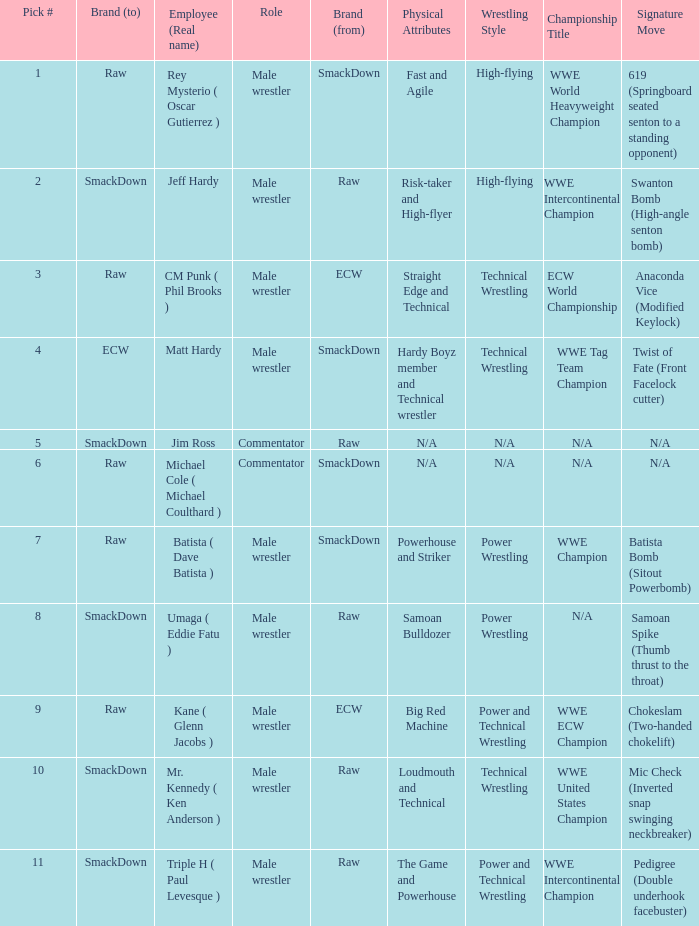What is the real name of the Pick # that is greater than 9? Mr. Kennedy ( Ken Anderson ), Triple H ( Paul Levesque ). Could you help me parse every detail presented in this table? {'header': ['Pick #', 'Brand (to)', 'Employee (Real name)', 'Role', 'Brand (from)', 'Physical Attributes', 'Wrestling Style', 'Championship Title', 'Signature Move'], 'rows': [['1', 'Raw', 'Rey Mysterio ( Oscar Gutierrez )', 'Male wrestler', 'SmackDown', 'Fast and Agile ', 'High-flying', 'WWE World Heavyweight Champion', '619 (Springboard seated senton to a standing opponent)'], ['2', 'SmackDown', 'Jeff Hardy', 'Male wrestler', 'Raw', 'Risk-taker and High-flyer', 'High-flying', 'WWE Intercontinental Champion', 'Swanton Bomb (High-angle senton bomb)'], ['3', 'Raw', 'CM Punk ( Phil Brooks )', 'Male wrestler', 'ECW', 'Straight Edge and Technical', 'Technical Wrestling', 'ECW World Championship', 'Anaconda Vice (Modified Keylock)'], ['4', 'ECW', 'Matt Hardy', 'Male wrestler', 'SmackDown', 'Hardy Boyz member and Technical wrestler', 'Technical Wrestling', 'WWE Tag Team Champion', 'Twist of Fate (Front Facelock cutter)'], ['5', 'SmackDown', 'Jim Ross', 'Commentator', 'Raw', 'N/A', 'N/A', 'N/A', 'N/A'], ['6', 'Raw', 'Michael Cole ( Michael Coulthard )', 'Commentator', 'SmackDown', 'N/A', 'N/A', 'N/A', 'N/A'], ['7', 'Raw', 'Batista ( Dave Batista )', 'Male wrestler', 'SmackDown', 'Powerhouse and Striker', 'Power Wrestling', 'WWE Champion', 'Batista Bomb (Sitout Powerbomb)'], ['8', 'SmackDown', 'Umaga ( Eddie Fatu )', 'Male wrestler', 'Raw', 'Samoan Bulldozer', 'Power Wrestling', 'N/A', 'Samoan Spike (Thumb thrust to the throat)'], ['9', 'Raw', 'Kane ( Glenn Jacobs )', 'Male wrestler', 'ECW', 'Big Red Machine', 'Power and Technical Wrestling', 'WWE ECW Champion', 'Chokeslam (Two-handed chokelift)'], ['10', 'SmackDown', 'Mr. Kennedy ( Ken Anderson )', 'Male wrestler', 'Raw', 'Loudmouth and Technical', 'Technical Wrestling', 'WWE United States Champion', 'Mic Check (Inverted snap swinging neckbreaker)'], ['11', 'SmackDown', 'Triple H ( Paul Levesque )', 'Male wrestler', 'Raw', 'The Game and Powerhouse', 'Power and Technical Wrestling', 'WWE Intercontinental Champion', 'Pedigree (Double underhook facebuster)']]} 